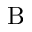<formula> <loc_0><loc_0><loc_500><loc_500>B</formula> 